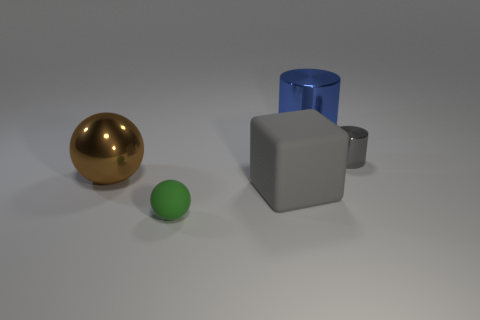The tiny cylinder that is made of the same material as the large brown sphere is what color?
Make the answer very short. Gray. There is a tiny thing that is behind the big block; does it have the same color as the large block?
Keep it short and to the point. Yes. There is a gray thing to the left of the big blue cylinder; what is it made of?
Your answer should be very brief. Rubber. Are there the same number of gray cylinders that are to the left of the big brown thing and blue metal objects?
Ensure brevity in your answer.  No. What number of large cylinders are the same color as the large rubber object?
Your response must be concise. 0. The other shiny thing that is the same shape as the small gray thing is what color?
Your response must be concise. Blue. Do the gray shiny object and the green matte sphere have the same size?
Make the answer very short. Yes. Is the number of large cylinders that are to the right of the tiny gray metal cylinder the same as the number of big blue metallic objects that are right of the blue metal object?
Provide a short and direct response. Yes. Are any tiny purple matte cylinders visible?
Give a very brief answer. No. What is the size of the other thing that is the same shape as the small gray object?
Your answer should be compact. Large. 